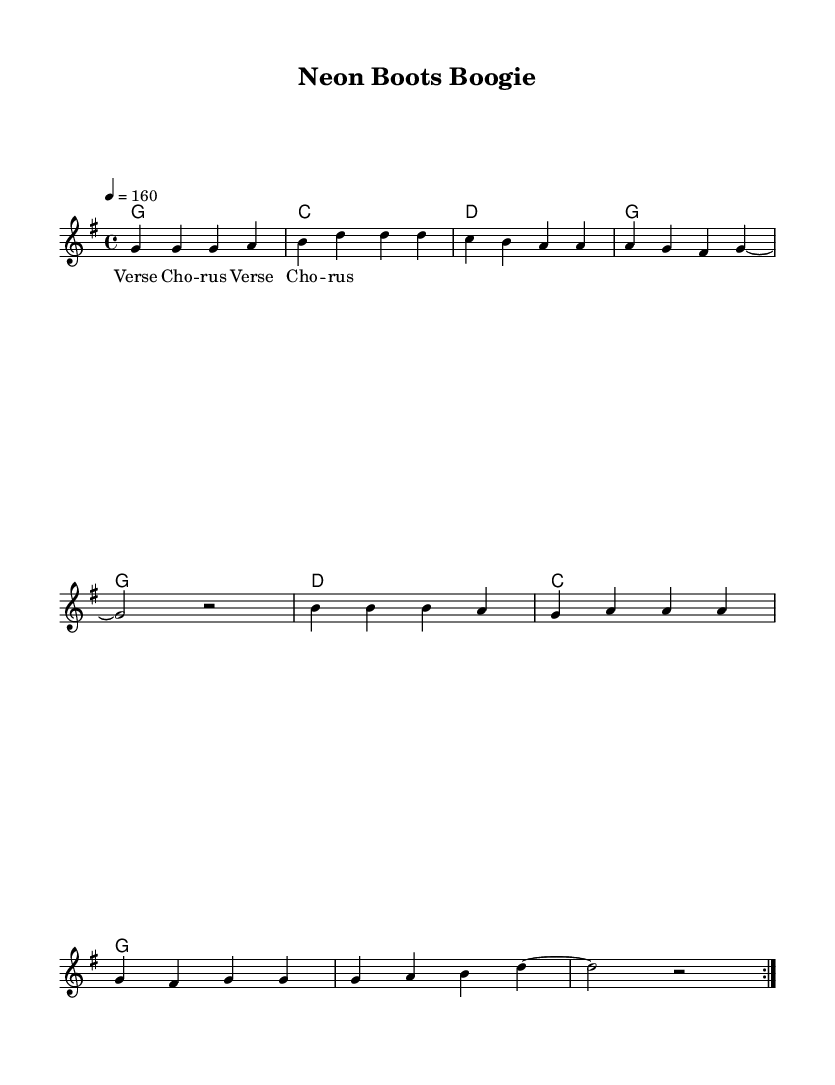What is the key signature of this music? The key signature indicates G major, which has one sharp (F#).
Answer: G major What is the time signature of this music? The time signature shown in the music is 4/4, meaning there are four beats per measure.
Answer: 4/4 What is the tempo marking for this piece? The tempo marking describes a speed of 160 beats per minute as indicated by the “4 = 160” notation.
Answer: 160 How many measures are in the verse section of this music? The verse section is repeated twice and consists of 4 measures per repeat, leading to a total of 8 measures.
Answer: 8 measures What is the first note of the chorus? The first note of the chorus is B, as indicated in the melody part at the start of that section.
Answer: B What is the relationship between the chord in the verse and the melody? The chords in the verse are primarily G major, C major, D major, and G major, which support the melody notes of the same name, creating harmonic coherence.
Answer: G major, C major, D major What section does the term "Chorus" refer to in the lyrics? The term "Chorus" refers to the part of the song that follows "Verse 1" and is repeated after each verse, typically highlighting the main theme.
Answer: Chorus 